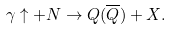Convert formula to latex. <formula><loc_0><loc_0><loc_500><loc_500>\gamma \uparrow + N \rightarrow Q ( \overline { Q } ) + X .</formula> 